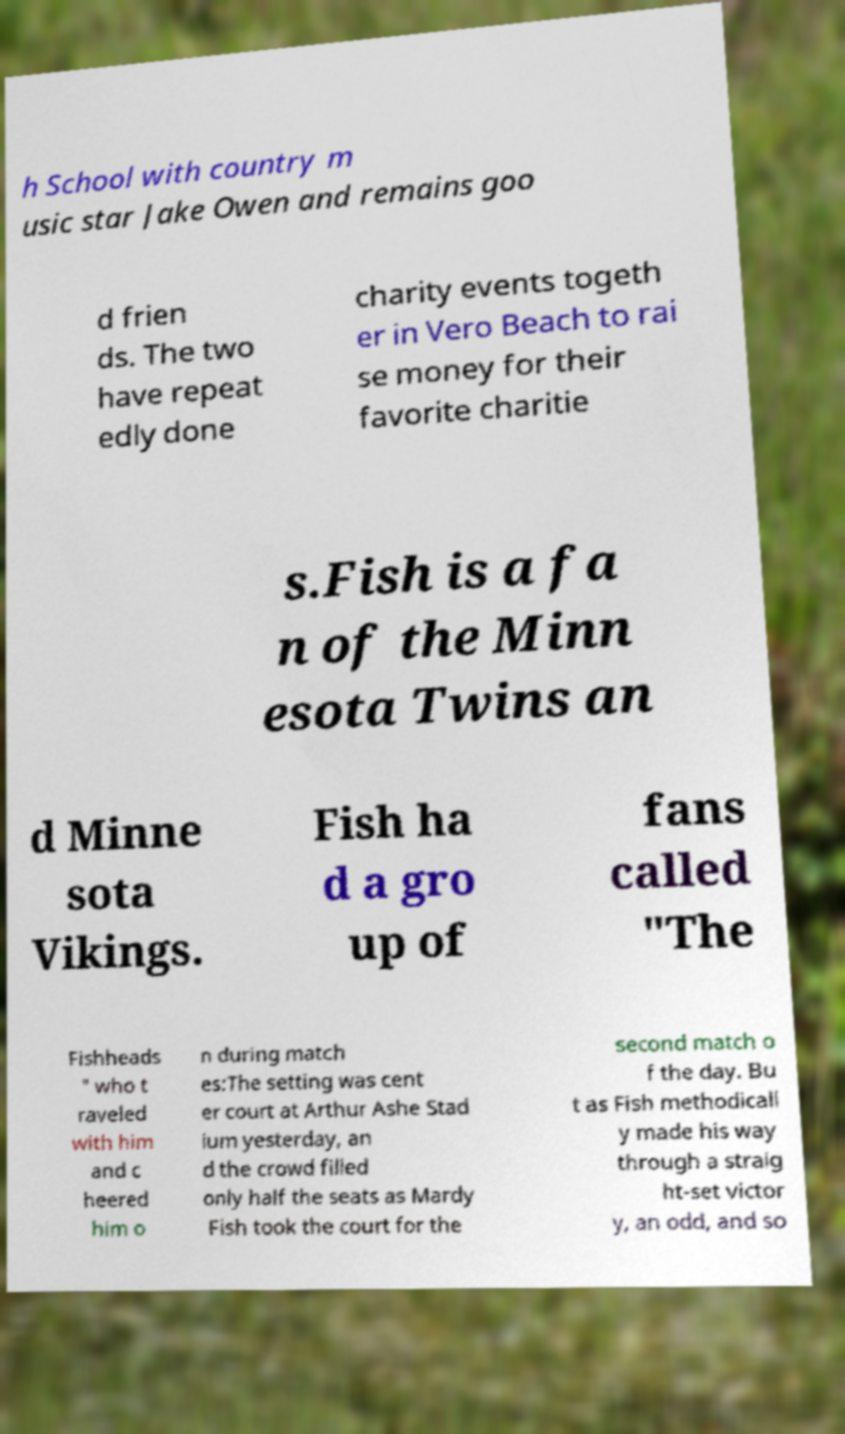Please identify and transcribe the text found in this image. h School with country m usic star Jake Owen and remains goo d frien ds. The two have repeat edly done charity events togeth er in Vero Beach to rai se money for their favorite charitie s.Fish is a fa n of the Minn esota Twins an d Minne sota Vikings. Fish ha d a gro up of fans called "The Fishheads " who t raveled with him and c heered him o n during match es:The setting was cent er court at Arthur Ashe Stad ium yesterday, an d the crowd filled only half the seats as Mardy Fish took the court for the second match o f the day. Bu t as Fish methodicall y made his way through a straig ht-set victor y, an odd, and so 